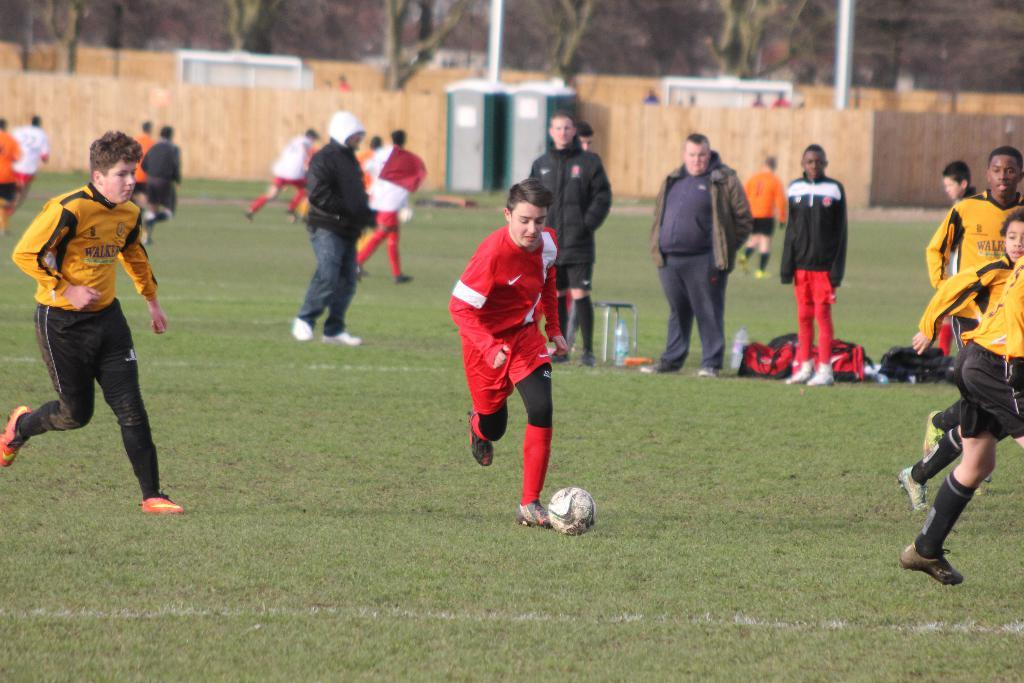What activity are the people in the image engaged in? There is a group of people playing football in the image. What can be seen in the background of the image? There is a wooden wall, a door, a pole, and a tree in the background of the image. What is the name of the dog that is playing with the football in the image? There is no dog present in the image, and therefore no name can be given. What type of engine is powering the football in the image? There is no engine present in the image, and the football is being played with manually by the group of people. 